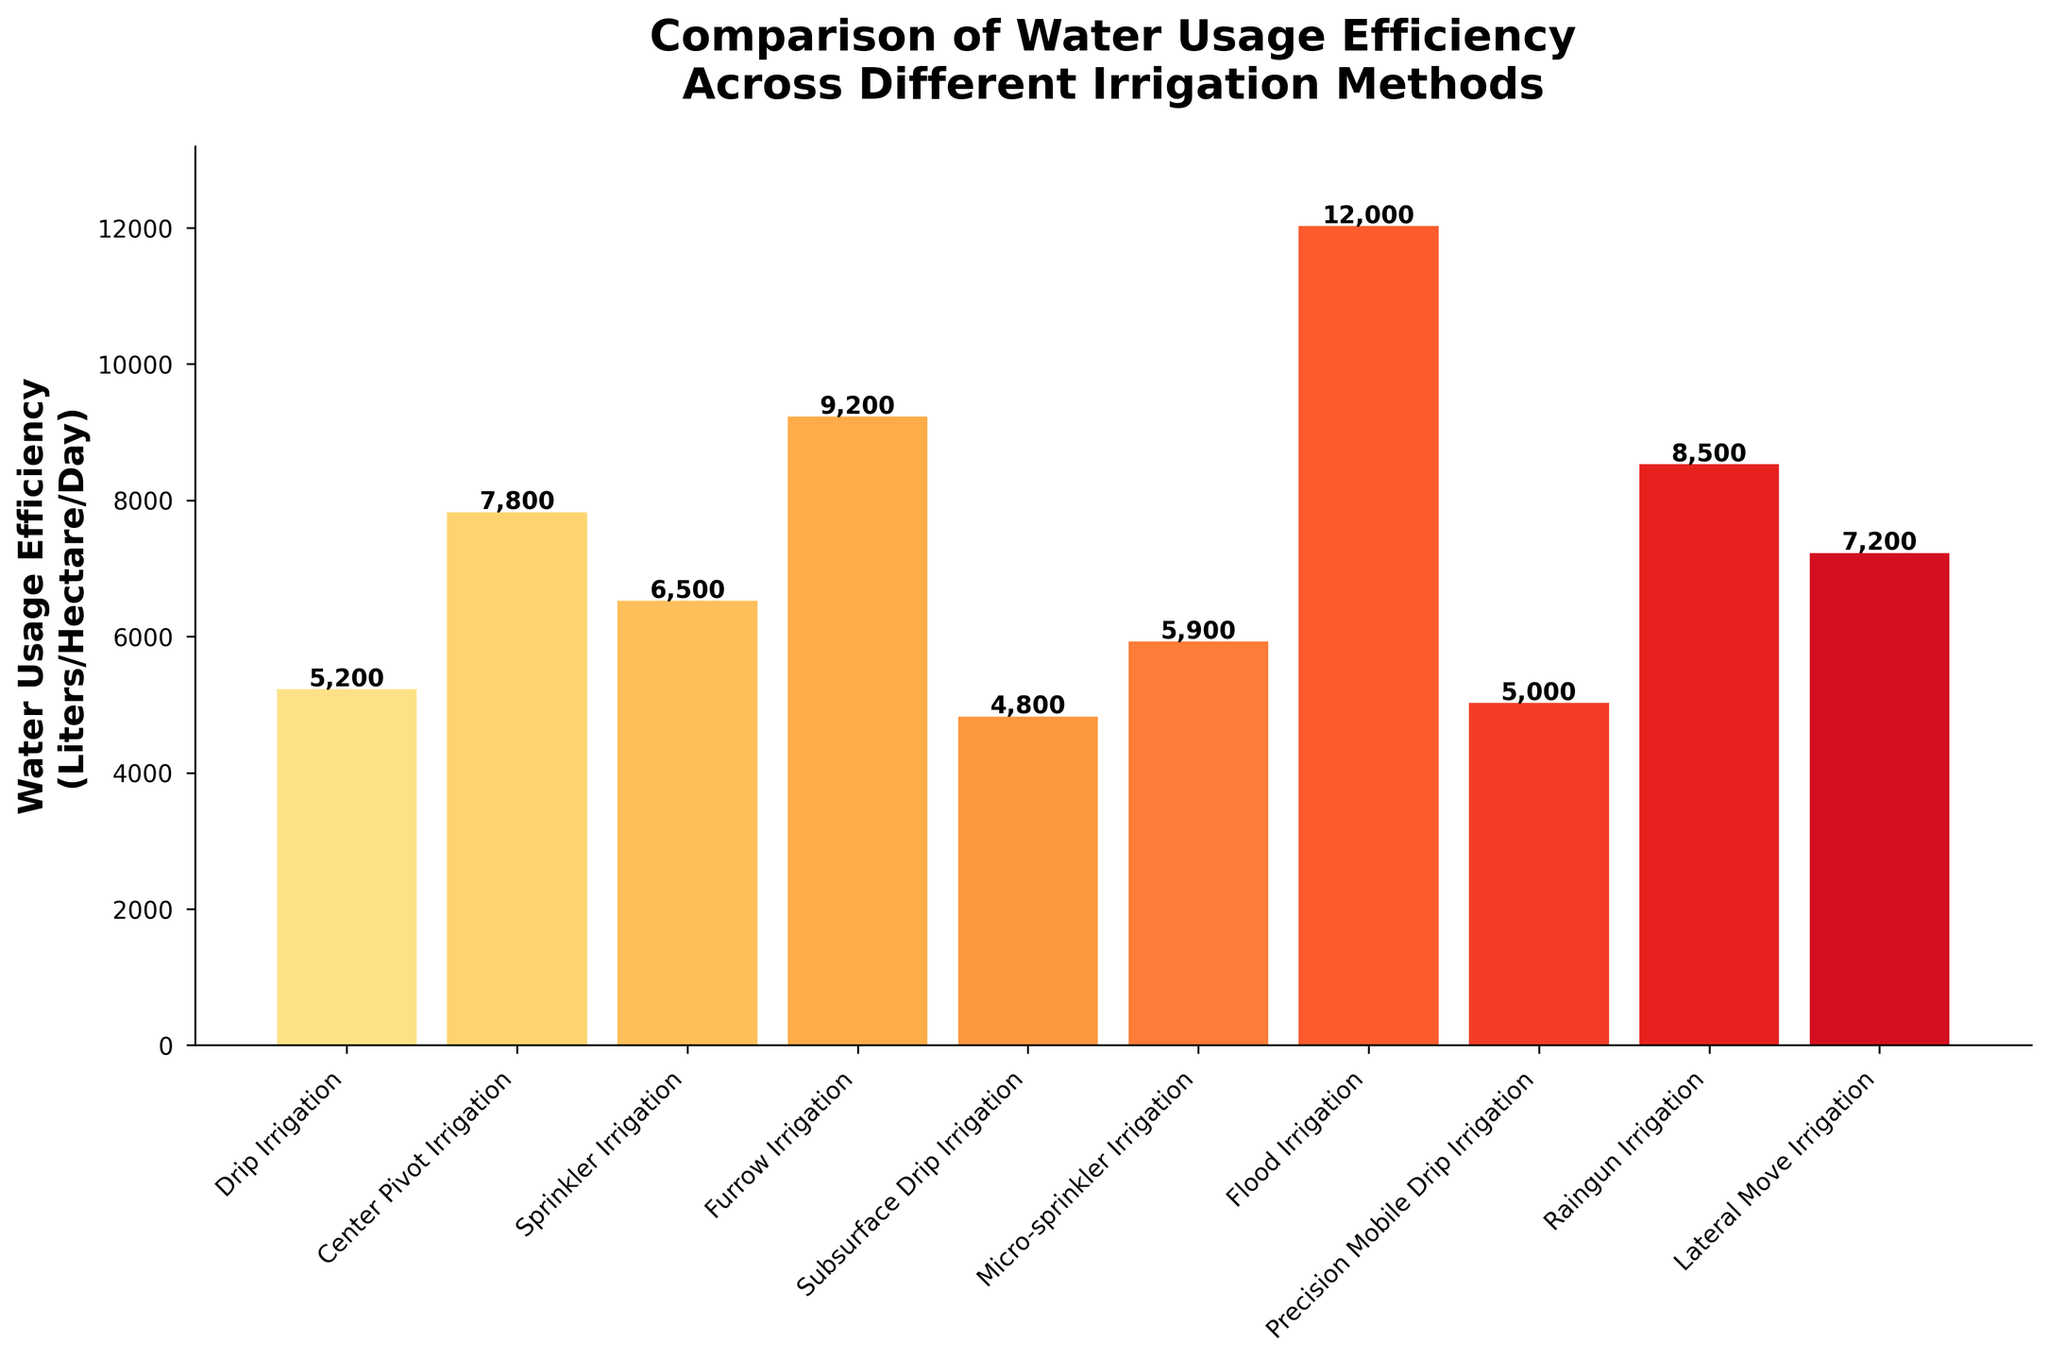Which irrigation method has the lowest water usage efficiency? The bar chart shows that Subsurface Drip Irrigation has the smallest height, representing the least water usage efficiency.
Answer: Subsurface Drip Irrigation What is the difference in water usage efficiency between Furrow Irrigation and Drip Irrigation? By comparing the height of the bars for Furrow Irrigation (9200 Liters/Hectare/Day) and Drip Irrigation (5200 Liters/Hectare/Day), the difference is 9200 - 5200.
Answer: 4000 What is the average water usage efficiency across all irrigation methods? Add all the values of water usage efficiency and divide by the number of methods: (5200 + 7800 + 6500 + 9200 + 4800 + 5900 + 12000 + 5000 + 8500 + 7200) / 10.
Answer: 7350 Which irrigation method is the least efficient, and what is its water usage efficiency? The bar chart indicates that the Flood Irrigation bar has the highest height, making it the least efficient. The water usage efficiency for Flood Irrigation is 12000 Liters/Hectare/Day.
Answer: Flood Irrigation, 12000 What is the combined water usage efficiency of Center Pivot Irrigation and Lateral Move Irrigation? Add the water usage efficiencies of Center Pivot Irrigation (7800 Liters/Hectare/Day) and Lateral Move Irrigation (7200 Liters/Hectare/Day): 7800 + 7200.
Answer: 15000 Among Drip Irrigation and Precision Mobile Drip Irrigation, which is more efficient and by how much? Comparing the bars, Drip Irrigation has a water usage efficiency of 5200 and Precision Mobile Drip Irrigation has 5000. The difference is 5200 - 5000.
Answer: Drip Irrigation, 200 Between Sprinkler Irrigation and Raingun Irrigation, which one uses more water? The bar for Raingun Irrigation is higher than Sprinkler Irrigation, indicating it uses more water. Sprinkler Irrigation is 6500 Liters/Hectare/Day and Raingun Irrigation is 8500 Liters/Hectare/Day.
Answer: Raingun Irrigation What is the range of water usage efficiency values in the figure? The lowest value is for Subsurface Drip Irrigation (4800 Liters/Hectare/Day) and the highest is Flood Irrigation (12000 Liters/Hectare/Day). The range is 12000 - 4800.
Answer: 7200 How does Micro-sprinkler Irrigation compare to Sprinkler Irrigation in terms of water usage efficiency? Comparing the two bars, Micro-sprinkler Irrigation has a lower height (5900) compared to Sprinkler Irrigation (6500), indicating it is more efficient.
Answer: Micro-sprinkler Irrigation is more efficient Which irrigation method falls exactly in the middle in terms of water usage efficiency when all methods are sorted? Sorting the methods by efficiency values, the middle value (median) of sorted data (4800, 5000, 5200, 5900, 6500, 7200, 7800, 8500, 9200, 12000) is the average of 6500 and 7200.
Answer: Lateral Move Irrigation 